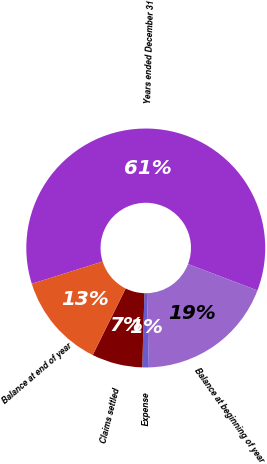Convert chart. <chart><loc_0><loc_0><loc_500><loc_500><pie_chart><fcel>Years ended December 31<fcel>Balance at beginning of year<fcel>Expense<fcel>Claims settled<fcel>Balance at end of year<nl><fcel>60.63%<fcel>18.81%<fcel>0.88%<fcel>6.86%<fcel>12.83%<nl></chart> 